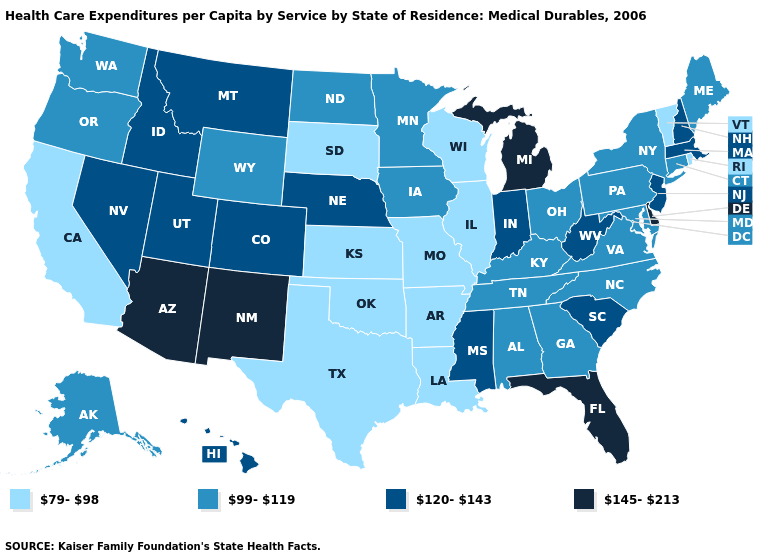Name the states that have a value in the range 79-98?
Answer briefly. Arkansas, California, Illinois, Kansas, Louisiana, Missouri, Oklahoma, Rhode Island, South Dakota, Texas, Vermont, Wisconsin. Which states hav the highest value in the Northeast?
Answer briefly. Massachusetts, New Hampshire, New Jersey. Name the states that have a value in the range 79-98?
Write a very short answer. Arkansas, California, Illinois, Kansas, Louisiana, Missouri, Oklahoma, Rhode Island, South Dakota, Texas, Vermont, Wisconsin. What is the lowest value in states that border New Mexico?
Concise answer only. 79-98. Does Montana have the highest value in the West?
Answer briefly. No. What is the highest value in the MidWest ?
Concise answer only. 145-213. Among the states that border Minnesota , does South Dakota have the highest value?
Concise answer only. No. Among the states that border New York , which have the highest value?
Write a very short answer. Massachusetts, New Jersey. What is the lowest value in the South?
Write a very short answer. 79-98. What is the value of Nebraska?
Quick response, please. 120-143. Does Tennessee have a lower value than Florida?
Answer briefly. Yes. Name the states that have a value in the range 120-143?
Be succinct. Colorado, Hawaii, Idaho, Indiana, Massachusetts, Mississippi, Montana, Nebraska, Nevada, New Hampshire, New Jersey, South Carolina, Utah, West Virginia. What is the value of Wyoming?
Answer briefly. 99-119. Name the states that have a value in the range 120-143?
Keep it brief. Colorado, Hawaii, Idaho, Indiana, Massachusetts, Mississippi, Montana, Nebraska, Nevada, New Hampshire, New Jersey, South Carolina, Utah, West Virginia. Among the states that border Louisiana , does Texas have the lowest value?
Keep it brief. Yes. 